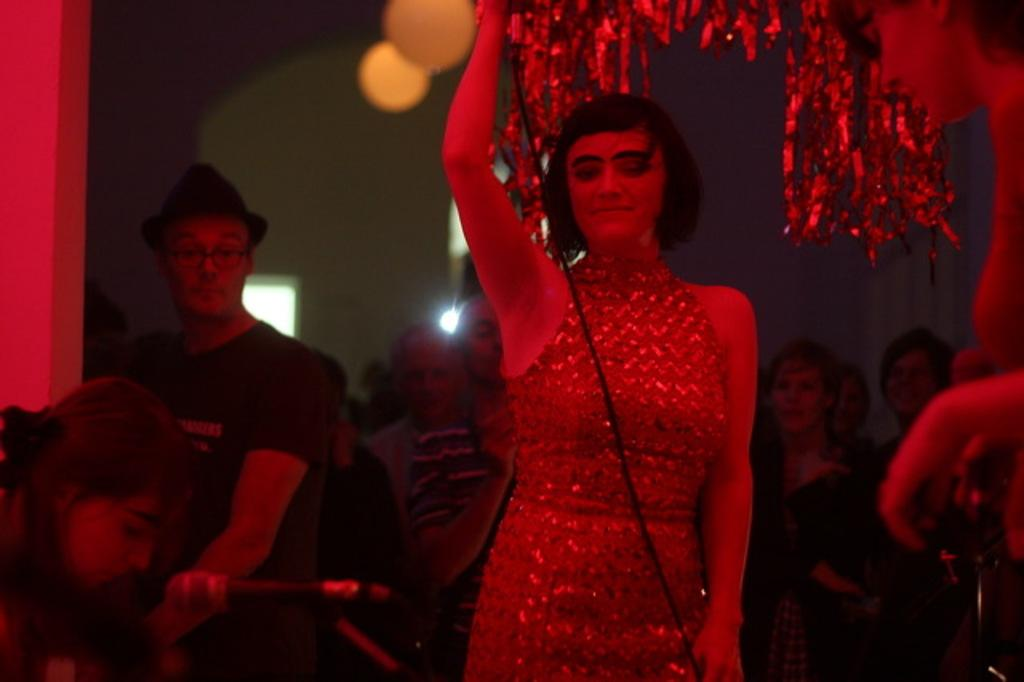Who is the main subject in the image? There is a woman in the center of the image. What is the woman doing in the image? The woman is holding an object. Can you describe the other people in the image? There is a group of people in the image. What can be seen in the background of the image? There are walls in the background of the image. What type of disease is being treated by the woman in the image? There is no indication of a disease or any medical treatment in the image. The woman is simply holding an object. 